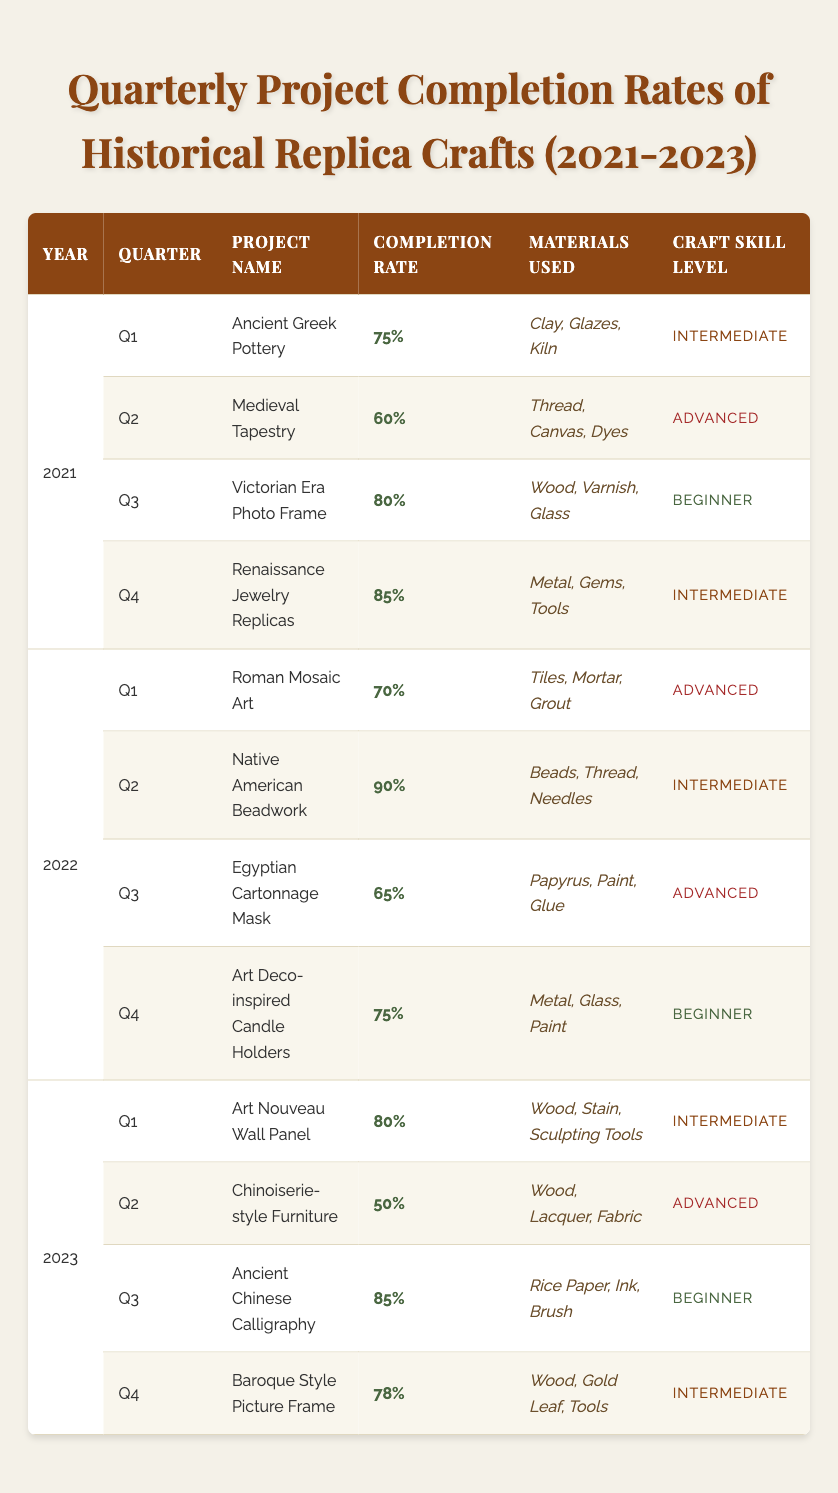What was the completion rate for the Renaissance Jewelry Replicas project in 2021? In the table, under the year 2021, in the fourth quarter (Q4), the completion rate for the Renaissance Jewelry Replicas project is listed as 85%.
Answer: 85% Which project had the highest completion rate in 2022? Looking across 2022, the completion rates for the projects are 70%, 90%, 65%, and 75%. The highest of these is 90%, which corresponds to the Native American Beadwork project in Q2.
Answer: Native American Beadwork What was the average completion rate for all projects in 2021? The completion rates for 2021 are 75%, 60%, 80%, and 85%. Adding these rates gives 300%. Dividing by the number of projects (4) yields an average of 75%.
Answer: 75% Was the completion rate for the Chinoiserie-style Furniture project in 2023 above or below 60%? The completion rate for the Chinoiserie-style Furniture project in Q2 of 2023 is 50%, which is below 60%.
Answer: Below Which quarter in 2023 had the highest completion rate and what was it? In 2023, the completion rates by quarter are 80% (Q1), 50% (Q2), 85% (Q3), and 78% (Q4). The highest rate is 85% during Q3, for the Ancient Chinese Calligraphy project.
Answer: Q3, 85% How many projects had a completion rate of 80% or higher in 2021? In 2021, the completion rates are 75%, 60%, 80%, and 85%. Two rates, 80% and 85%, are at or above 80%, corresponding to the Victorian Era Photo Frame and Renaissance Jewelry Replicas projects.
Answer: 2 Was there any project in 2022 that had a completion rate below 70%? The project completion rates in 2022 were 70%, 90%, 65%, and 75%. The rate of 65% for the Egyptian Cartonnage Mask is below 70%.
Answer: Yes Which year's projects had the overall lowest average completion rate? Calculating the averages: 2021 has (75 + 60 + 80 + 85) / 4 = 75%; 2022 has (70 + 90 + 65 + 75) / 4 = 75%; and 2023 has (80 + 50 + 85 + 78) / 4 = 73.25%. Thus, 2023 has the lowest average rate.
Answer: 2023 Among the projects from 2023, which had the highest skill level and what was its completion rate? The skill levels in 2023 are Intermediate for Q1 and Q4, Advanced for Q2, and Beginner for Q3. The Advanced project, Chinoiserie-style Furniture, has a completion rate of 50%, which is lower than the other projects. The highest completion rate among all projects is from Q3, which has Beginner skill level and is 85%.
Answer: Q3, 85% What was the completion rate difference between the best and worst project outcomes in 2022? The best completion rate in 2022 is 90% for the Native American Beadwork, while the worst is 65% for the Egyptian Cartonnage Mask. The difference is 90% - 65% = 25%.
Answer: 25% 